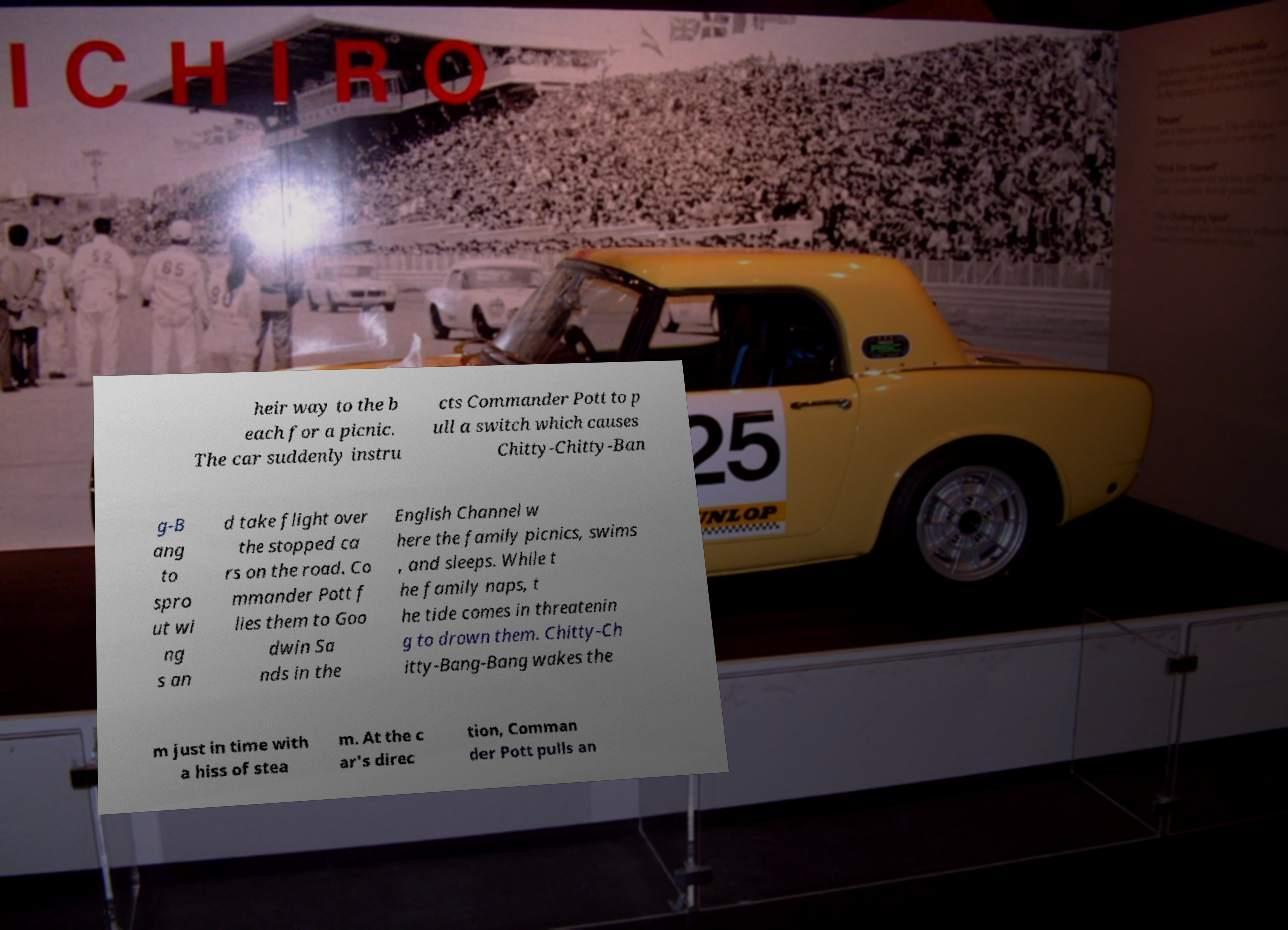Could you extract and type out the text from this image? heir way to the b each for a picnic. The car suddenly instru cts Commander Pott to p ull a switch which causes Chitty-Chitty-Ban g-B ang to spro ut wi ng s an d take flight over the stopped ca rs on the road. Co mmander Pott f lies them to Goo dwin Sa nds in the English Channel w here the family picnics, swims , and sleeps. While t he family naps, t he tide comes in threatenin g to drown them. Chitty-Ch itty-Bang-Bang wakes the m just in time with a hiss of stea m. At the c ar's direc tion, Comman der Pott pulls an 